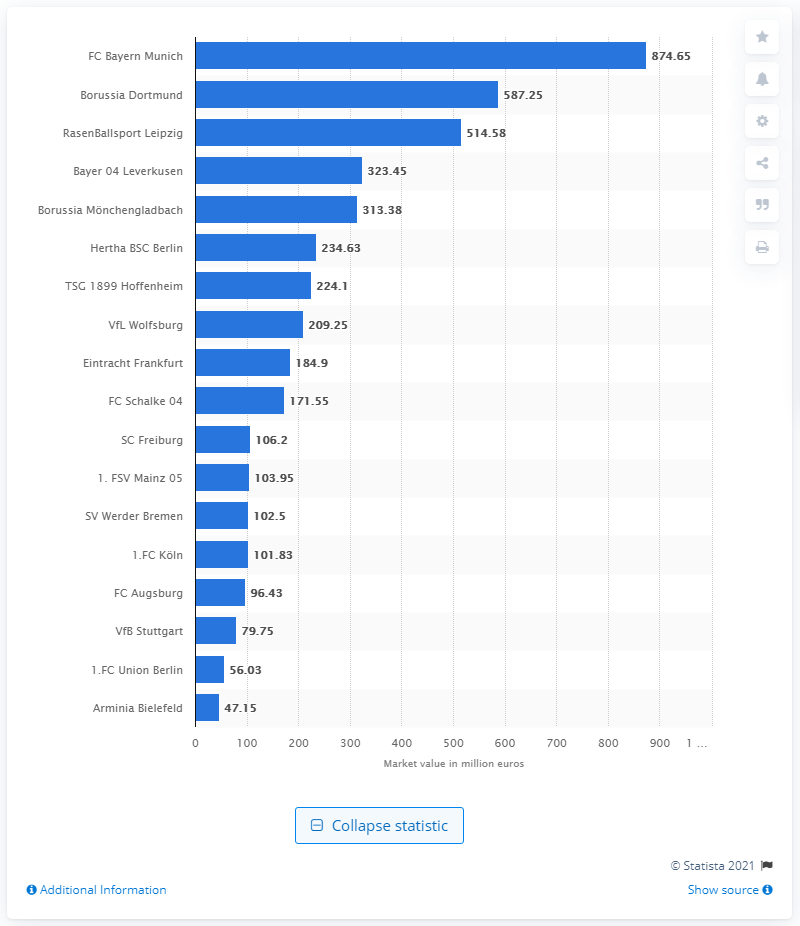Draw attention to some important aspects in this diagram. In 2020, Bayern Munich had a total market value of 874.65. 